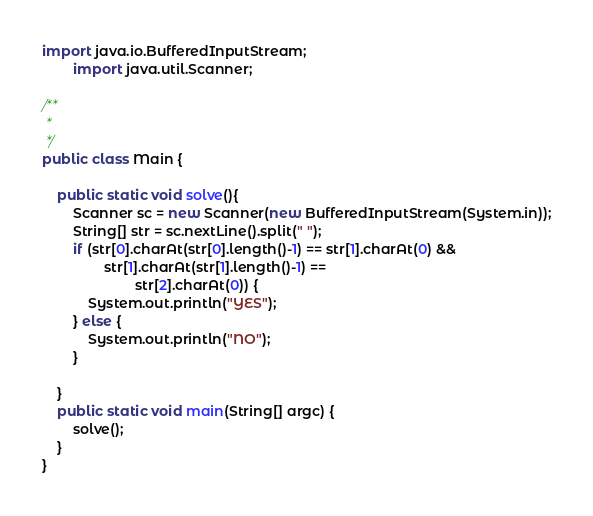<code> <loc_0><loc_0><loc_500><loc_500><_Java_>import java.io.BufferedInputStream;
        import java.util.Scanner;

/**
 *
 */
public class Main {

    public static void solve(){
        Scanner sc = new Scanner(new BufferedInputStream(System.in));
        String[] str = sc.nextLine().split(" ");
        if (str[0].charAt(str[0].length()-1) == str[1].charAt(0) &&
                str[1].charAt(str[1].length()-1) ==
                        str[2].charAt(0)) {
            System.out.println("YES");
        } else {
            System.out.println("NO");
        }

    }
    public static void main(String[] argc) {
        solve();
    }
}
</code> 